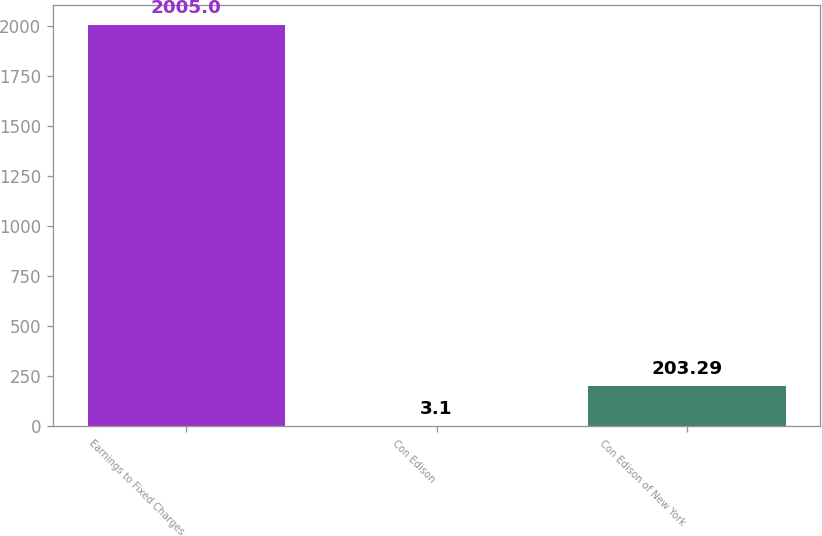<chart> <loc_0><loc_0><loc_500><loc_500><bar_chart><fcel>Earnings to Fixed Charges<fcel>Con Edison<fcel>Con Edison of New York<nl><fcel>2005<fcel>3.1<fcel>203.29<nl></chart> 